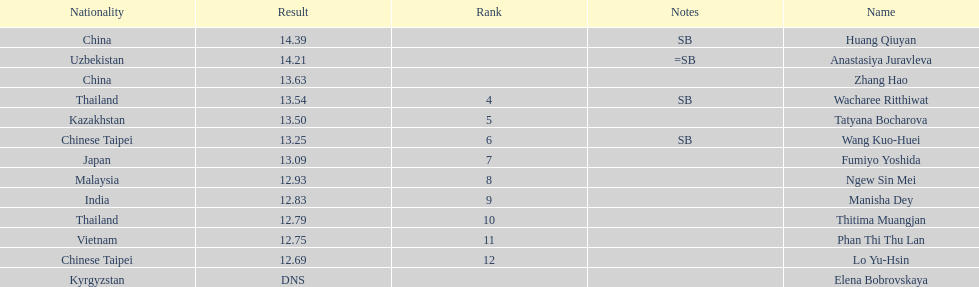How many competitors had less than 13.00 points? 6. Would you mind parsing the complete table? {'header': ['Nationality', 'Result', 'Rank', 'Notes', 'Name'], 'rows': [['China', '14.39', '', 'SB', 'Huang Qiuyan'], ['Uzbekistan', '14.21', '', '=SB', 'Anastasiya Juravleva'], ['China', '13.63', '', '', 'Zhang Hao'], ['Thailand', '13.54', '4', 'SB', 'Wacharee Ritthiwat'], ['Kazakhstan', '13.50', '5', '', 'Tatyana Bocharova'], ['Chinese Taipei', '13.25', '6', 'SB', 'Wang Kuo-Huei'], ['Japan', '13.09', '7', '', 'Fumiyo Yoshida'], ['Malaysia', '12.93', '8', '', 'Ngew Sin Mei'], ['India', '12.83', '9', '', 'Manisha Dey'], ['Thailand', '12.79', '10', '', 'Thitima Muangjan'], ['Vietnam', '12.75', '11', '', 'Phan Thi Thu Lan'], ['Chinese Taipei', '12.69', '12', '', 'Lo Yu-Hsin'], ['Kyrgyzstan', 'DNS', '', '', 'Elena Bobrovskaya']]} 